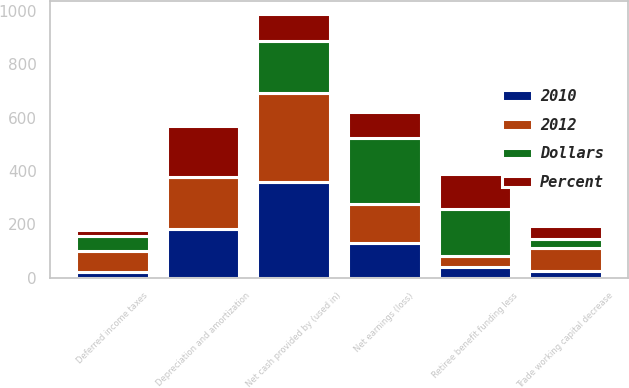<chart> <loc_0><loc_0><loc_500><loc_500><stacked_bar_chart><ecel><fcel>Net earnings (loss)<fcel>Deferred income taxes<fcel>Depreciation and amortization<fcel>Retiree benefit funding less<fcel>Trade working capital decrease<fcel>Net cash provided by (used in)<nl><fcel>2012<fcel>146<fcel>79<fcel>193<fcel>43<fcel>84<fcel>332<nl><fcel>Percent<fcel>100<fcel>23<fcel>190<fcel>132<fcel>49<fcel>100<nl><fcel>2010<fcel>131<fcel>21<fcel>183<fcel>39<fcel>27<fcel>359<nl><fcel>Dollars<fcel>246<fcel>56<fcel>3<fcel>175<fcel>35<fcel>196<nl></chart> 